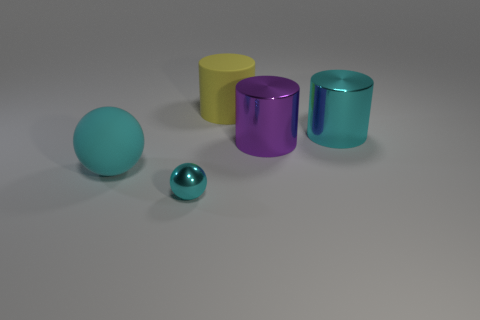Subtract all yellow cylinders. How many cylinders are left? 2 Subtract 1 cylinders. How many cylinders are left? 2 Subtract all brown cylinders. Subtract all yellow spheres. How many cylinders are left? 3 Add 3 blue rubber cylinders. How many objects exist? 8 Subtract all cylinders. How many objects are left? 2 Subtract all big cyan balls. Subtract all cyan metallic balls. How many objects are left? 3 Add 2 big matte balls. How many big matte balls are left? 3 Add 4 yellow matte objects. How many yellow matte objects exist? 5 Subtract 0 red cylinders. How many objects are left? 5 